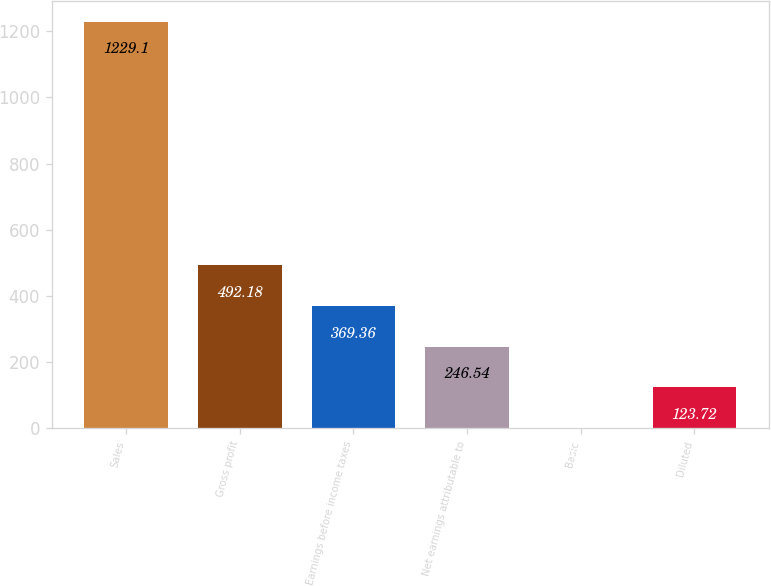Convert chart to OTSL. <chart><loc_0><loc_0><loc_500><loc_500><bar_chart><fcel>Sales<fcel>Gross profit<fcel>Earnings before income taxes<fcel>Net earnings attributable to<fcel>Basic<fcel>Diluted<nl><fcel>1229.1<fcel>492.18<fcel>369.36<fcel>246.54<fcel>0.9<fcel>123.72<nl></chart> 